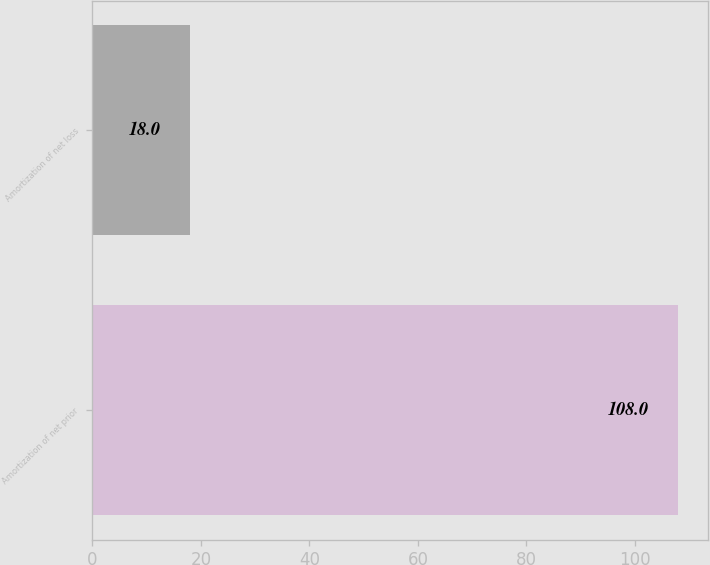Convert chart to OTSL. <chart><loc_0><loc_0><loc_500><loc_500><bar_chart><fcel>Amortization of net prior<fcel>Amortization of net loss<nl><fcel>108<fcel>18<nl></chart> 